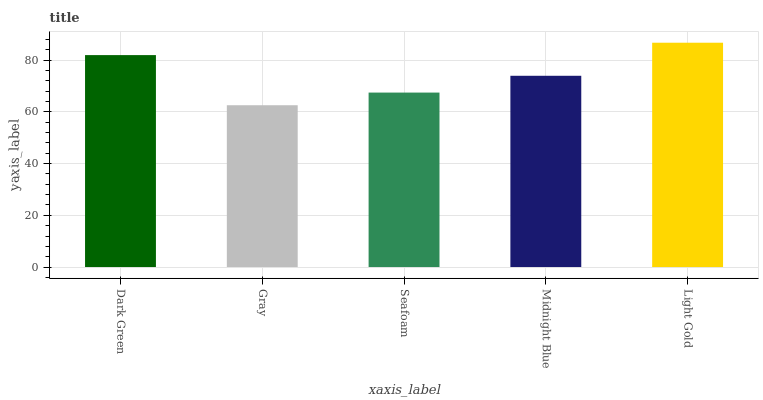Is Gray the minimum?
Answer yes or no. Yes. Is Light Gold the maximum?
Answer yes or no. Yes. Is Seafoam the minimum?
Answer yes or no. No. Is Seafoam the maximum?
Answer yes or no. No. Is Seafoam greater than Gray?
Answer yes or no. Yes. Is Gray less than Seafoam?
Answer yes or no. Yes. Is Gray greater than Seafoam?
Answer yes or no. No. Is Seafoam less than Gray?
Answer yes or no. No. Is Midnight Blue the high median?
Answer yes or no. Yes. Is Midnight Blue the low median?
Answer yes or no. Yes. Is Dark Green the high median?
Answer yes or no. No. Is Seafoam the low median?
Answer yes or no. No. 